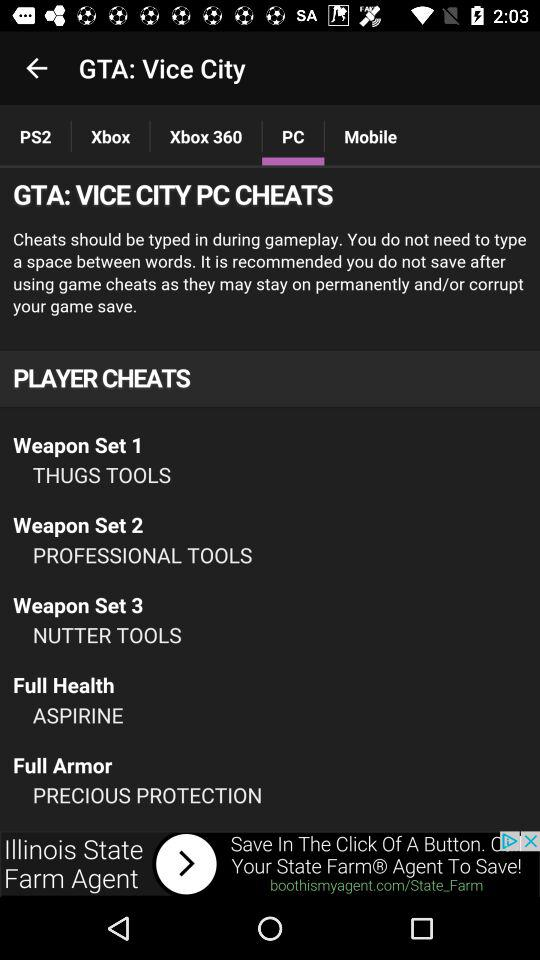How many cheats are there for weapons?
Answer the question using a single word or phrase. 3 